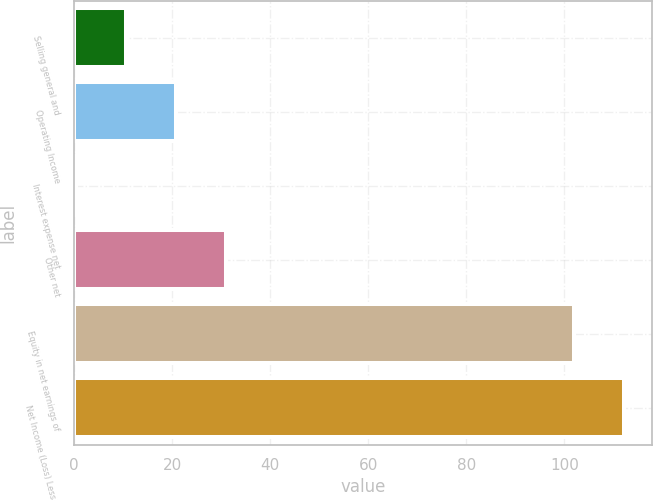Convert chart to OTSL. <chart><loc_0><loc_0><loc_500><loc_500><bar_chart><fcel>Selling general and<fcel>Operating Income<fcel>Interest expense net<fcel>Other net<fcel>Equity in net earnings of<fcel>Net Income (Loss) Less Net<nl><fcel>10.58<fcel>20.74<fcel>0.42<fcel>30.9<fcel>102<fcel>112.16<nl></chart> 